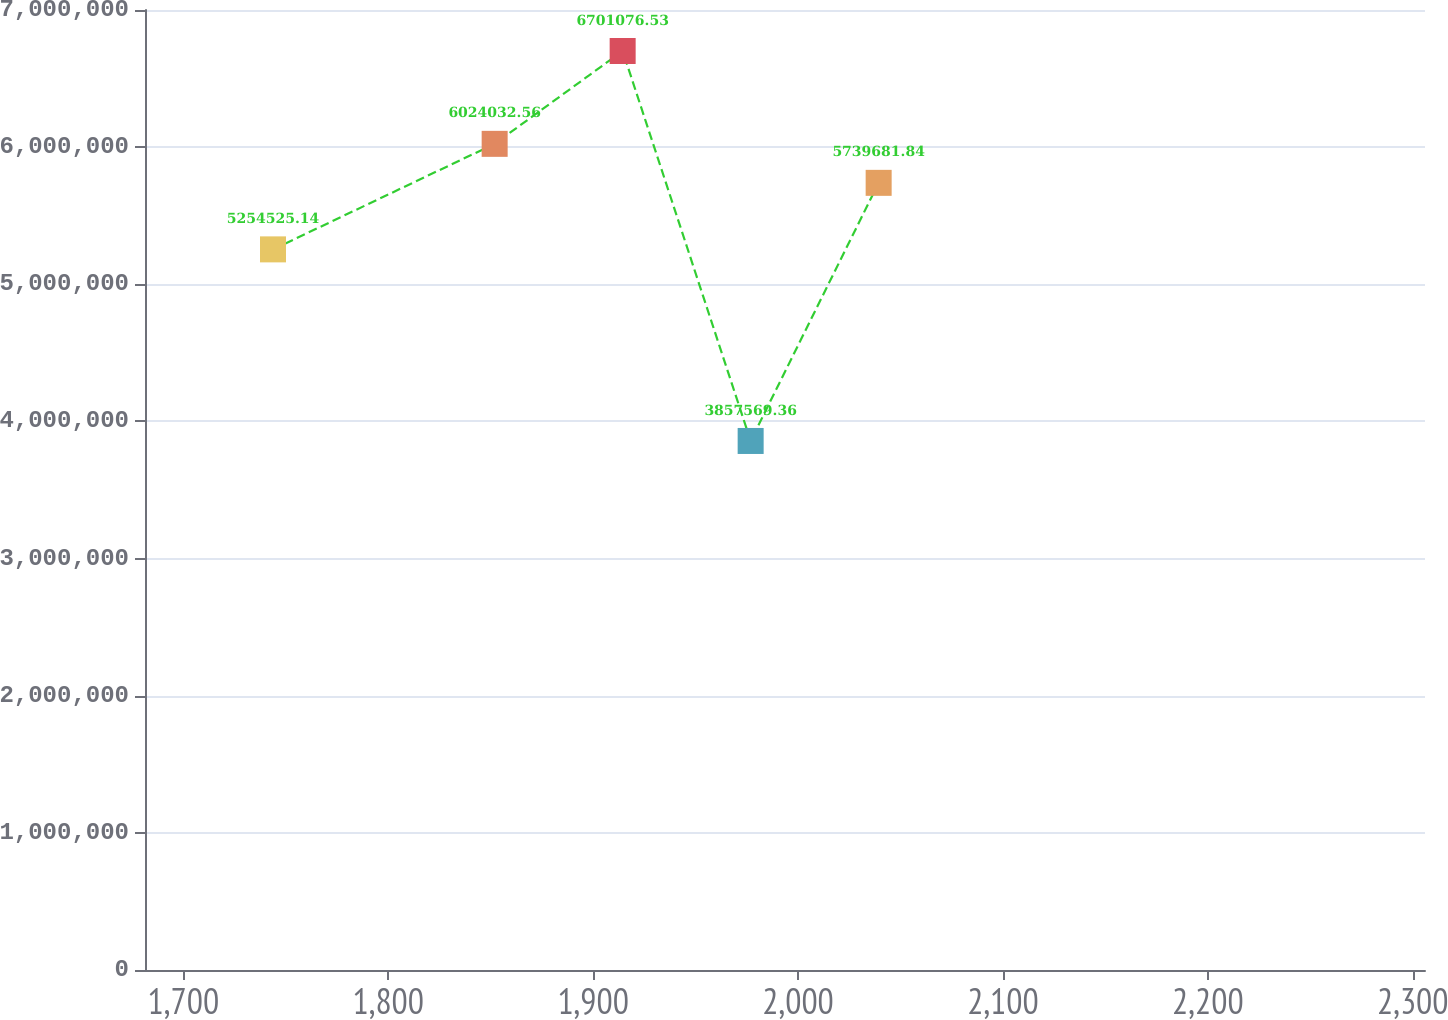<chart> <loc_0><loc_0><loc_500><loc_500><line_chart><ecel><fcel>Unnamed: 1<nl><fcel>1743.75<fcel>5.25453e+06<nl><fcel>1851.93<fcel>6.02403e+06<nl><fcel>1914.4<fcel>6.70108e+06<nl><fcel>1976.87<fcel>3.85757e+06<nl><fcel>2039.34<fcel>5.73968e+06<nl><fcel>2368.46<fcel>4.7945e+06<nl></chart> 